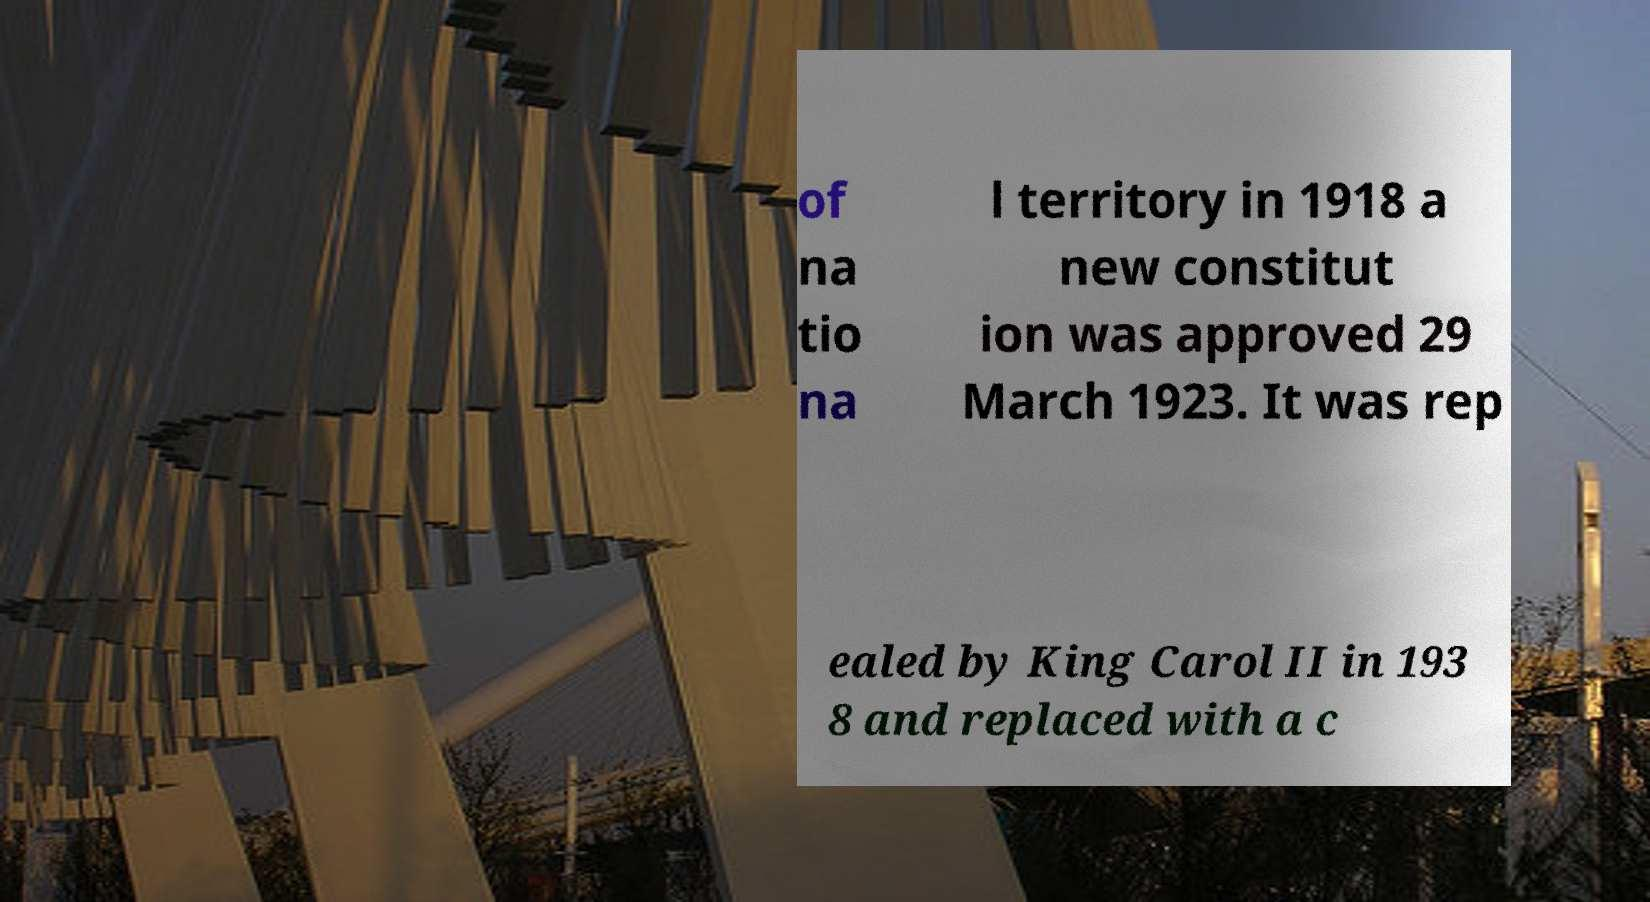What messages or text are displayed in this image? I need them in a readable, typed format. of na tio na l territory in 1918 a new constitut ion was approved 29 March 1923. It was rep ealed by King Carol II in 193 8 and replaced with a c 